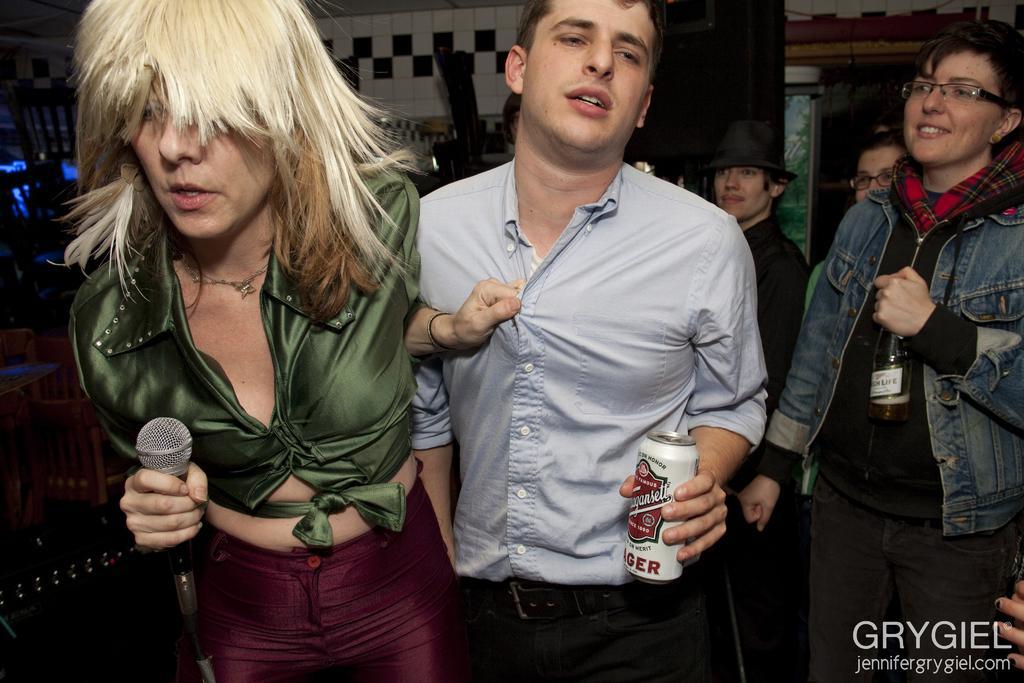How would you summarize this image in a sentence or two? In this image there are persons standing, there are persons truncated towards the bottom of the image, there are persons holding objects, there is a person truncated towards the right of the image, at the bottom of the image there is text, there are objects truncated towards the left of the image, there are chairs, there is an object truncated towards the top of the image, there are objects behind the person, there is wall truncated towards the top of the image. 